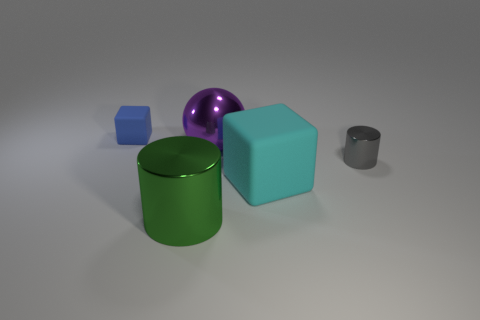There is a blue object that is made of the same material as the large cyan object; what size is it?
Make the answer very short. Small. How many large blue objects are the same shape as the green metallic object?
Your answer should be very brief. 0. There is a green thing; is it the same shape as the small object in front of the tiny rubber cube?
Make the answer very short. Yes. Are there any large purple things that have the same material as the small blue object?
Provide a short and direct response. No. What is the material of the tiny object that is left of the matte object that is on the right side of the small matte block?
Your response must be concise. Rubber. What is the size of the cylinder that is in front of the tiny thing that is in front of the rubber cube that is behind the big cyan thing?
Provide a short and direct response. Large. How many other things are there of the same shape as the big purple metal object?
Your response must be concise. 0. What is the color of the rubber cube that is the same size as the gray cylinder?
Your answer should be very brief. Blue. Is there a large cylinder of the same color as the large rubber cube?
Provide a short and direct response. No. There is a cube that is in front of the blue rubber block; does it have the same size as the small gray cylinder?
Provide a succinct answer. No. 